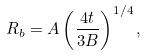<formula> <loc_0><loc_0><loc_500><loc_500>R _ { b } = A \left ( \frac { 4 t } { 3 B } \right ) ^ { 1 / 4 } ,</formula> 